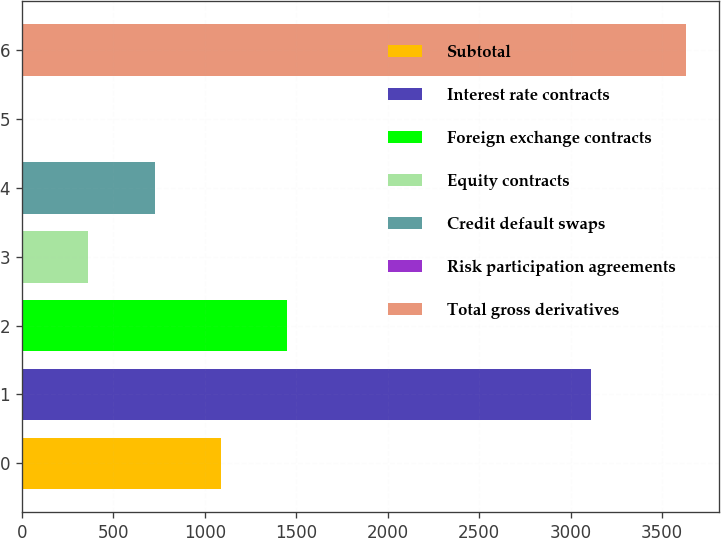Convert chart to OTSL. <chart><loc_0><loc_0><loc_500><loc_500><bar_chart><fcel>Subtotal<fcel>Interest rate contracts<fcel>Foreign exchange contracts<fcel>Equity contracts<fcel>Credit default swaps<fcel>Risk participation agreements<fcel>Total gross derivatives<nl><fcel>1089.8<fcel>3110<fcel>1452.4<fcel>364.6<fcel>727.2<fcel>2<fcel>3628<nl></chart> 